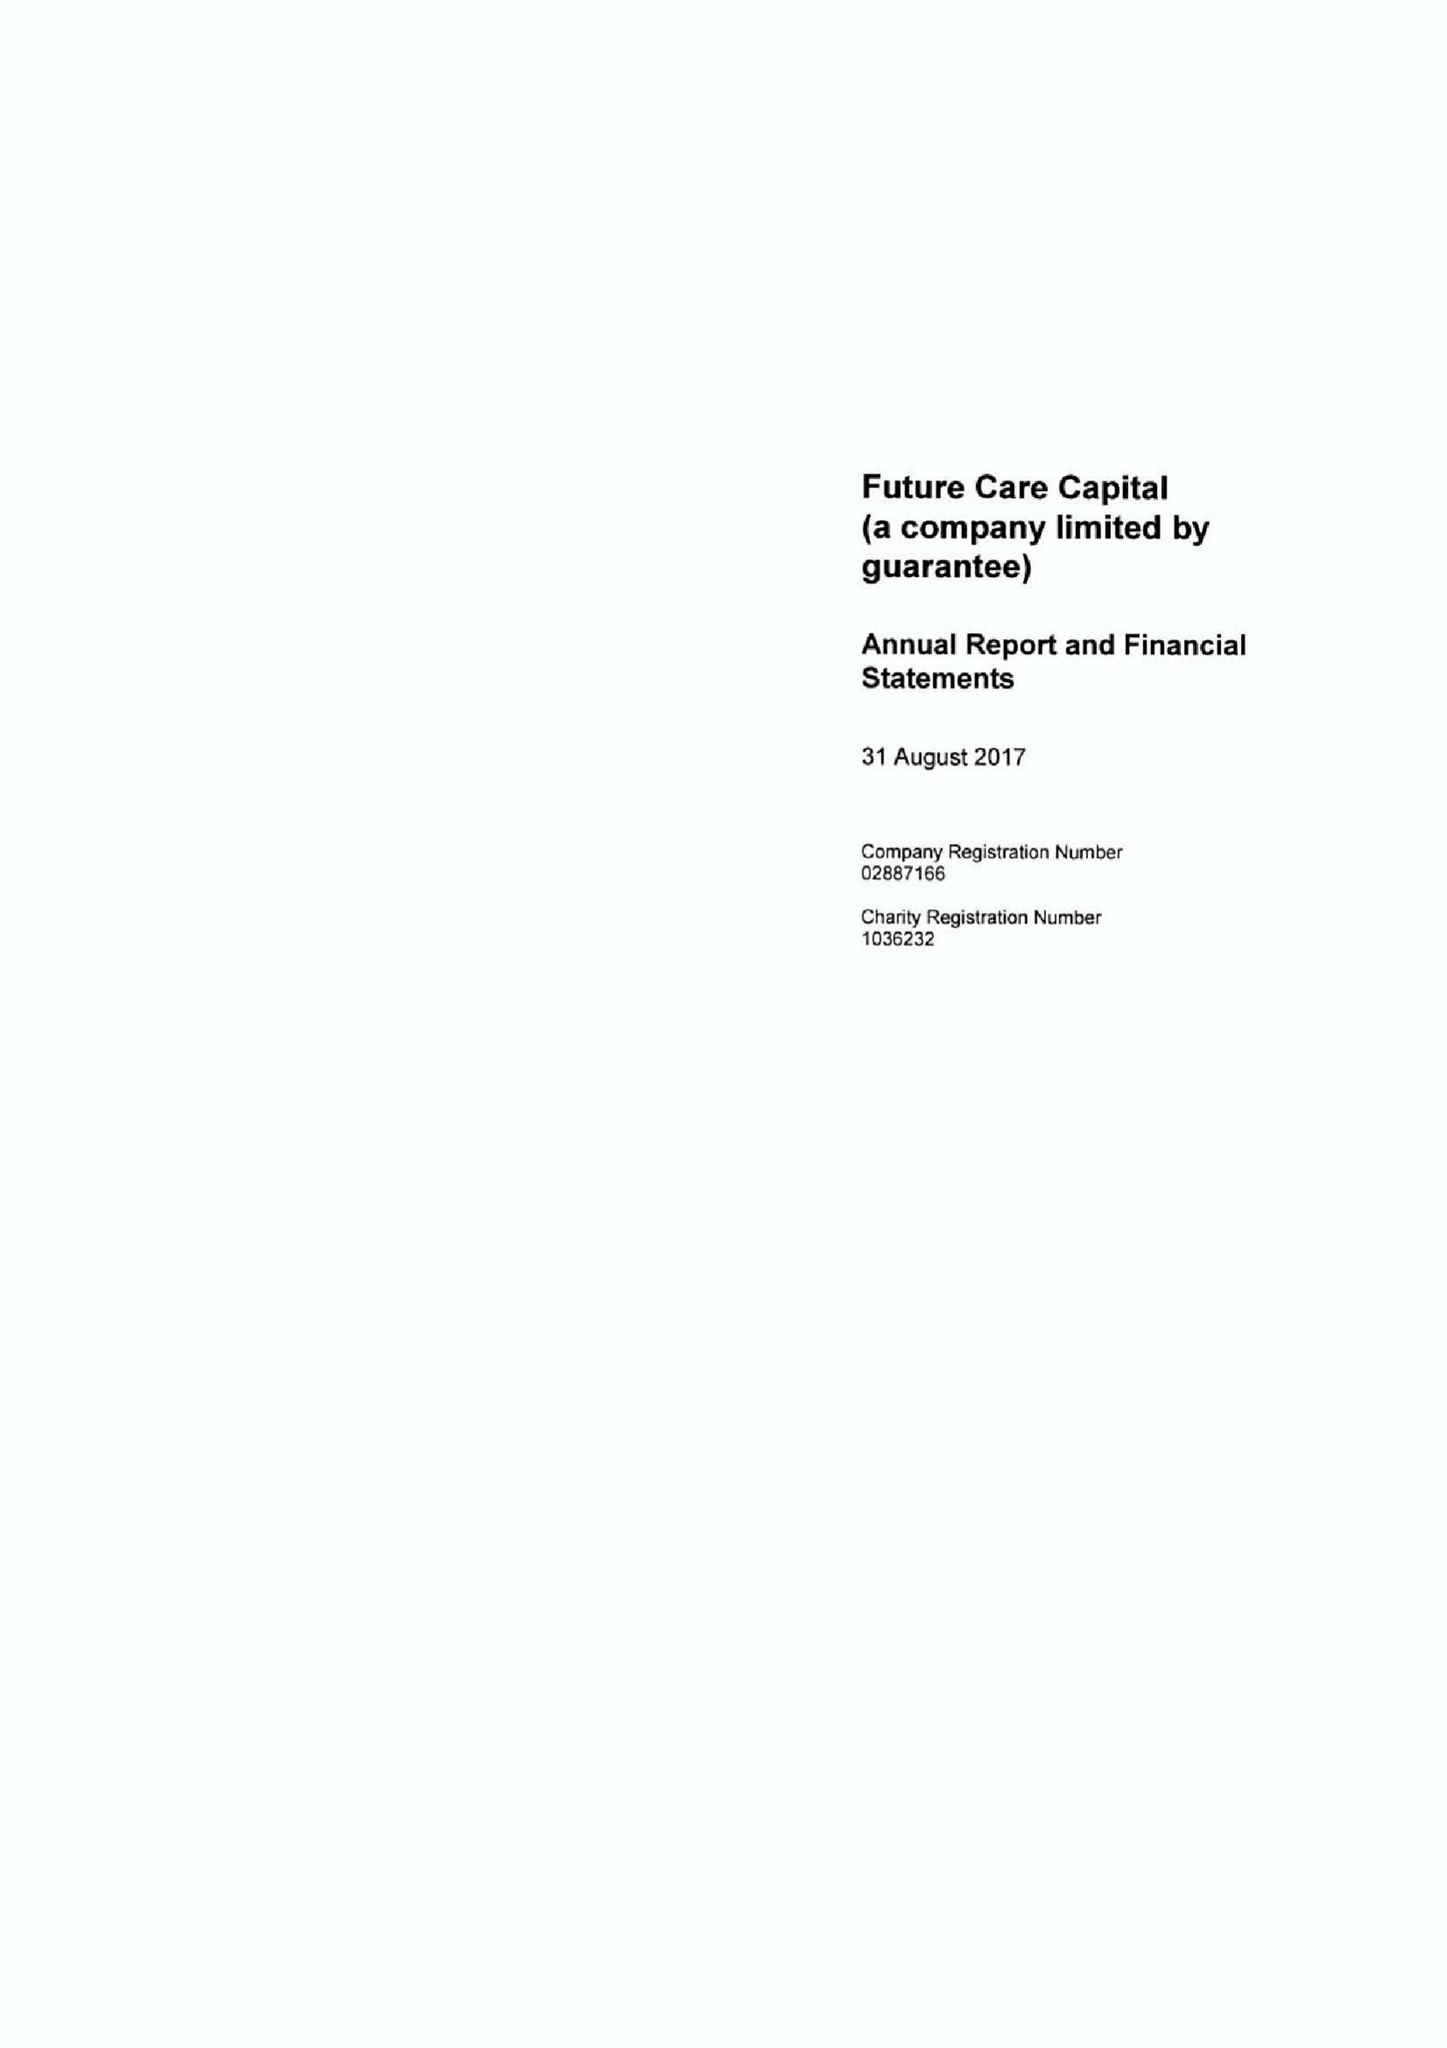What is the value for the address__street_line?
Answer the question using a single word or phrase. 38-44 GILLINGHAM STREET 